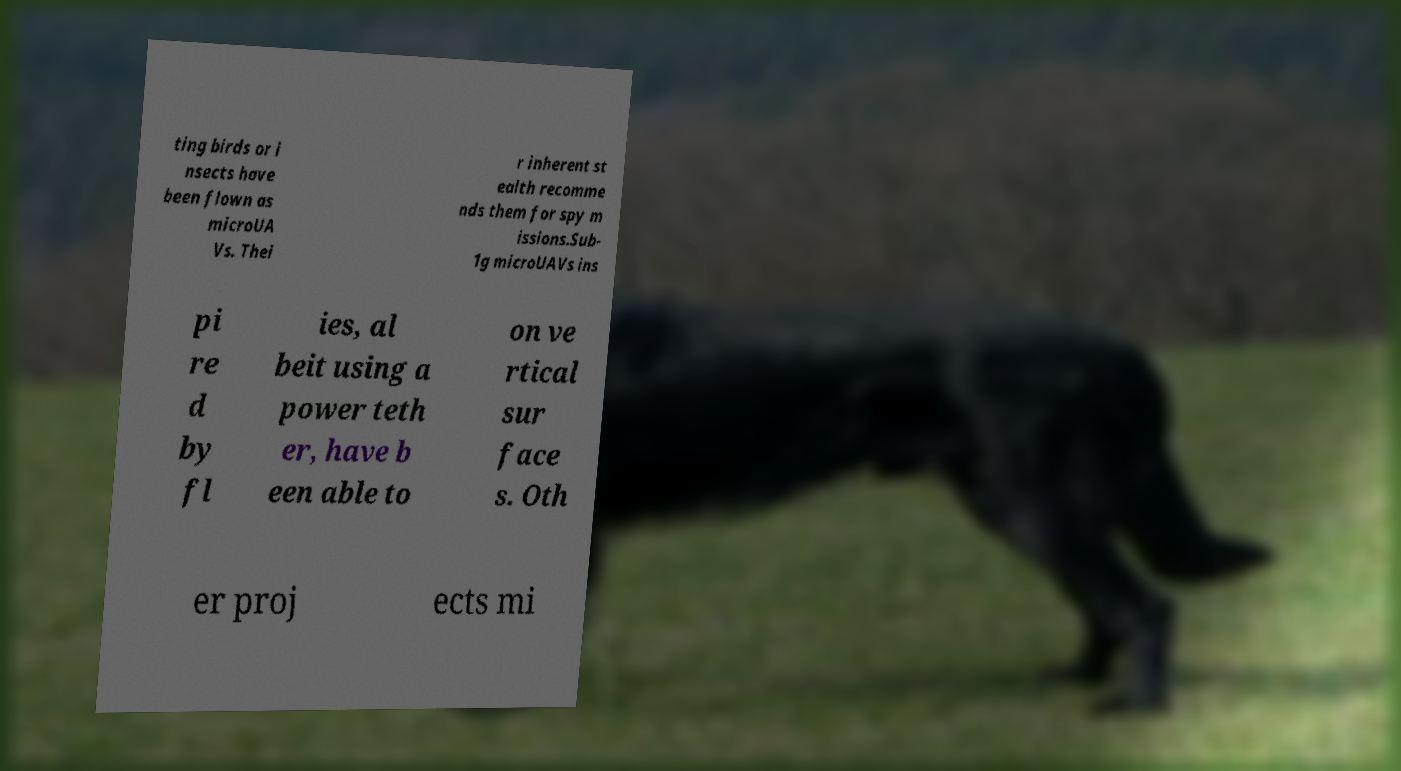Could you assist in decoding the text presented in this image and type it out clearly? ting birds or i nsects have been flown as microUA Vs. Thei r inherent st ealth recomme nds them for spy m issions.Sub- 1g microUAVs ins pi re d by fl ies, al beit using a power teth er, have b een able to on ve rtical sur face s. Oth er proj ects mi 